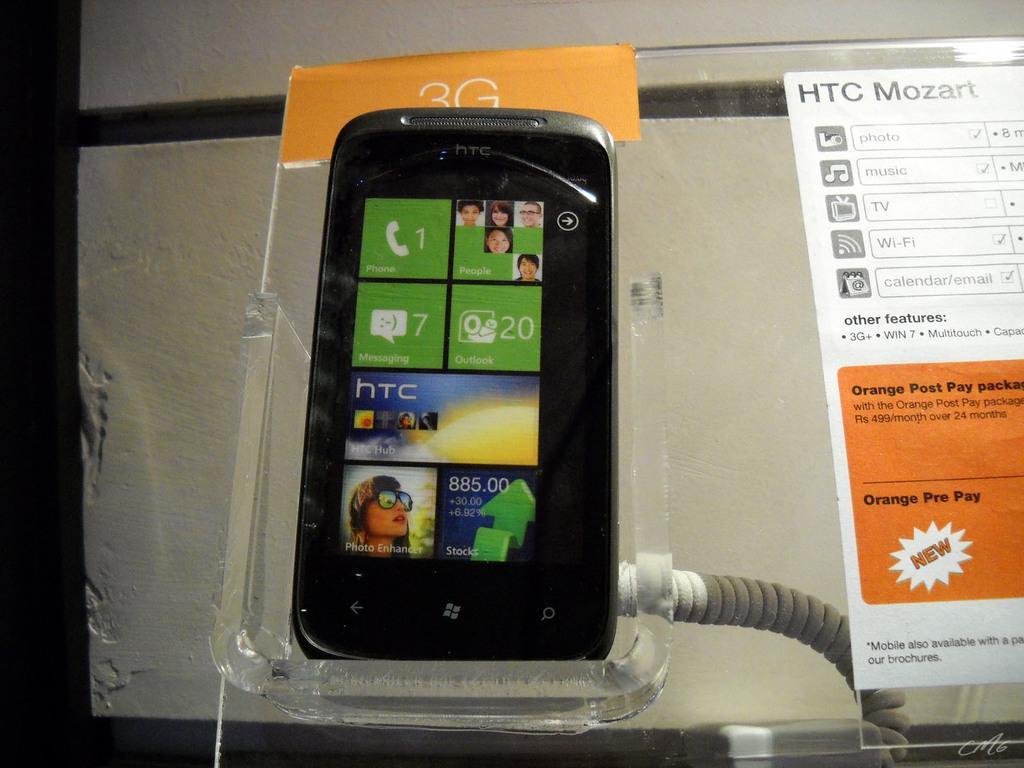How would you summarize this image in a sentence or two? In this image, we can see a mobile with screen is placed on the glass stand. Here we can see two stickers. Here there is a wire. Background we can see the wall. 